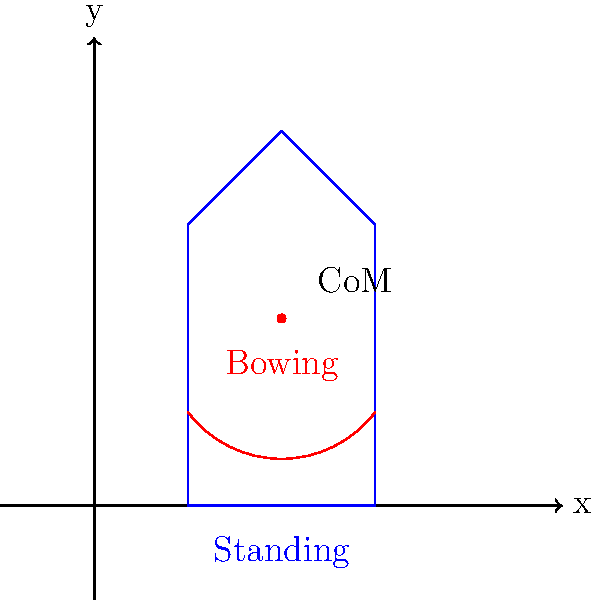In classic literature, characters often assume dramatic poses to convey emotion. Consider a scene where a character transitions from a standing position to a deep bow. How does this movement affect the character's center of mass (CoM), and what implications might this have for the scene's dramatic tension? To analyze the center of mass shift in this dramatic pose, let's consider the following steps:

1. Initial position (standing):
   - The character's CoM is typically located around the navel area, approximately at the midpoint of their height.
   - Let's assume the initial CoM is at coordinates (2, 2) in our diagram.

2. Bowing motion:
   - As the character bows, their upper body moves forward and downward.
   - The arms may extend, further shifting mass towards the front.

3. CoM shift:
   - The CoM will move forward and downward as the body bends.
   - The exact position depends on the depth of the bow and the character's body proportions.

4. Biomechanical implications:
   - Lower CoM increases stability but requires more effort to maintain balance.
   - The forward shift of CoM creates a moment arm, increasing torque on the lower back and legs.

5. Dramatic implications:
   - The lowered position physically represents submission or respect.
   - The increased effort to maintain this pose can convey tension or discomfort.
   - The character's ability to smoothly transition back to standing reflects their physical condition and emotional state.

6. Mathematical representation:
   - If we model the body as a simple rod of length $L$, the CoM in a bow of angle $\theta$ from vertical would be at:
     $x = \frac{L}{2}\sin\theta$
     $y = \frac{L}{2}\cos\theta$

7. Energy expenditure:
   - The potential energy change is given by $\Delta PE = mg\Delta h$, where $m$ is mass, $g$ is gravity, and $\Delta h$ is the change in height of the CoM.

In the context of scriptwriting, understanding this biomechanical shift can help in crafting more vivid descriptions and understanding the physical subtext of character interactions.
Answer: CoM shifts forward and downward, increasing dramatic tension through physical strain and symbolic lowering of status. 